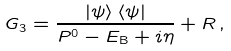<formula> <loc_0><loc_0><loc_500><loc_500>G _ { 3 } = \frac { \left | \psi \right \rangle \left \langle \psi \right | } { P ^ { 0 } - E _ { \text {B} } + i \eta } + R \, ,</formula> 